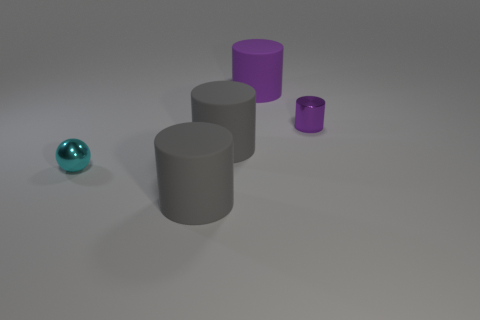Subtract all cyan blocks. How many purple cylinders are left? 2 Subtract all tiny cylinders. How many cylinders are left? 3 Add 1 cyan things. How many objects exist? 6 Subtract all cylinders. How many objects are left? 1 Subtract all cyan cylinders. Subtract all yellow balls. How many cylinders are left? 4 Subtract all large rubber objects. Subtract all small purple metallic objects. How many objects are left? 1 Add 5 balls. How many balls are left? 6 Add 5 small red balls. How many small red balls exist? 5 Subtract 0 purple spheres. How many objects are left? 5 